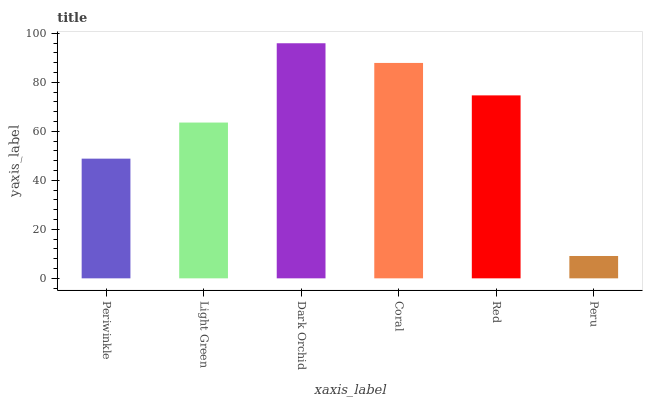Is Peru the minimum?
Answer yes or no. Yes. Is Dark Orchid the maximum?
Answer yes or no. Yes. Is Light Green the minimum?
Answer yes or no. No. Is Light Green the maximum?
Answer yes or no. No. Is Light Green greater than Periwinkle?
Answer yes or no. Yes. Is Periwinkle less than Light Green?
Answer yes or no. Yes. Is Periwinkle greater than Light Green?
Answer yes or no. No. Is Light Green less than Periwinkle?
Answer yes or no. No. Is Red the high median?
Answer yes or no. Yes. Is Light Green the low median?
Answer yes or no. Yes. Is Coral the high median?
Answer yes or no. No. Is Red the low median?
Answer yes or no. No. 